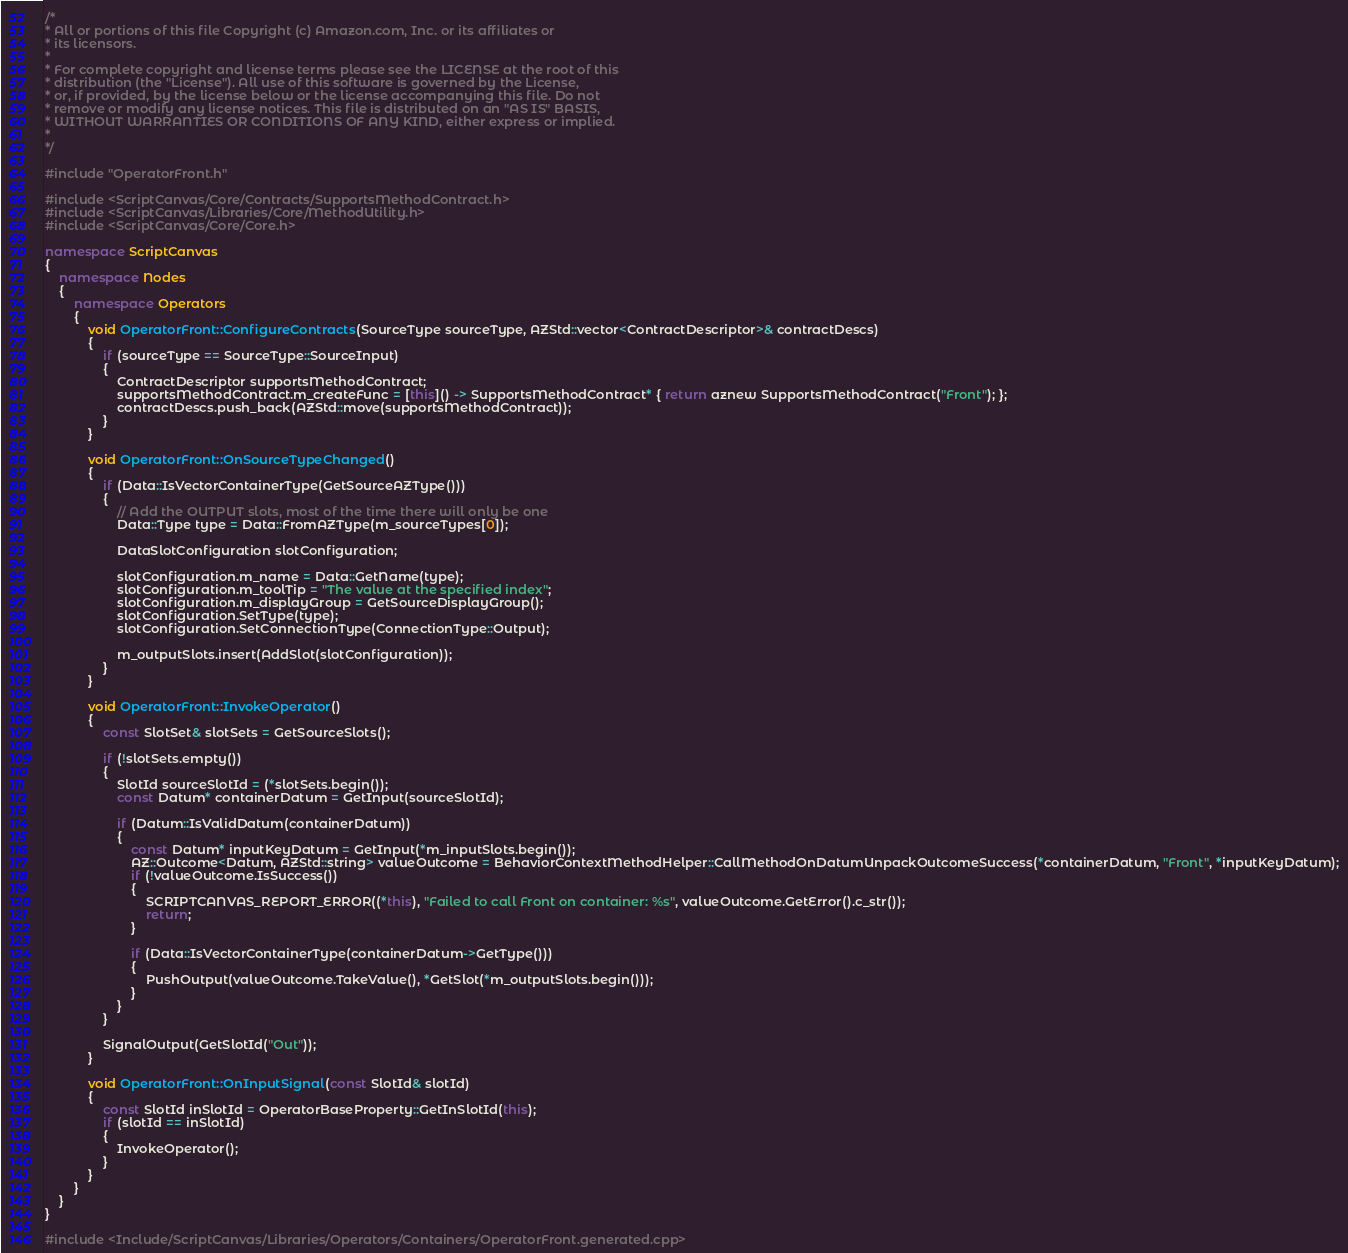<code> <loc_0><loc_0><loc_500><loc_500><_C++_>/*
* All or portions of this file Copyright (c) Amazon.com, Inc. or its affiliates or
* its licensors.
*
* For complete copyright and license terms please see the LICENSE at the root of this
* distribution (the "License"). All use of this software is governed by the License,
* or, if provided, by the license below or the license accompanying this file. Do not
* remove or modify any license notices. This file is distributed on an "AS IS" BASIS,
* WITHOUT WARRANTIES OR CONDITIONS OF ANY KIND, either express or implied.
*
*/

#include "OperatorFront.h"

#include <ScriptCanvas/Core/Contracts/SupportsMethodContract.h>
#include <ScriptCanvas/Libraries/Core/MethodUtility.h>
#include <ScriptCanvas/Core/Core.h>

namespace ScriptCanvas
{
    namespace Nodes
    {
        namespace Operators
        {
            void OperatorFront::ConfigureContracts(SourceType sourceType, AZStd::vector<ContractDescriptor>& contractDescs)
            {
                if (sourceType == SourceType::SourceInput)
                {
                    ContractDescriptor supportsMethodContract;
                    supportsMethodContract.m_createFunc = [this]() -> SupportsMethodContract* { return aznew SupportsMethodContract("Front"); };
                    contractDescs.push_back(AZStd::move(supportsMethodContract));
                }
            }

            void OperatorFront::OnSourceTypeChanged()
            {
                if (Data::IsVectorContainerType(GetSourceAZType()))
                {
                    // Add the OUTPUT slots, most of the time there will only be one
                    Data::Type type = Data::FromAZType(m_sourceTypes[0]);

                    DataSlotConfiguration slotConfiguration;

                    slotConfiguration.m_name = Data::GetName(type);
                    slotConfiguration.m_toolTip = "The value at the specified index";
                    slotConfiguration.m_displayGroup = GetSourceDisplayGroup();
                    slotConfiguration.SetType(type);
                    slotConfiguration.SetConnectionType(ConnectionType::Output);

                    m_outputSlots.insert(AddSlot(slotConfiguration));
                }
            }

            void OperatorFront::InvokeOperator()
            {
                const SlotSet& slotSets = GetSourceSlots();

                if (!slotSets.empty())
                {
                    SlotId sourceSlotId = (*slotSets.begin());
                    const Datum* containerDatum = GetInput(sourceSlotId);

                    if (Datum::IsValidDatum(containerDatum))
                    {
                        const Datum* inputKeyDatum = GetInput(*m_inputSlots.begin());
                        AZ::Outcome<Datum, AZStd::string> valueOutcome = BehaviorContextMethodHelper::CallMethodOnDatumUnpackOutcomeSuccess(*containerDatum, "Front", *inputKeyDatum);
                        if (!valueOutcome.IsSuccess())
                        {
                            SCRIPTCANVAS_REPORT_ERROR((*this), "Failed to call Front on container: %s", valueOutcome.GetError().c_str());
                            return;
                        }

                        if (Data::IsVectorContainerType(containerDatum->GetType()))
                        {
                            PushOutput(valueOutcome.TakeValue(), *GetSlot(*m_outputSlots.begin()));
                        }
                    }
                }

                SignalOutput(GetSlotId("Out"));
            }

            void OperatorFront::OnInputSignal(const SlotId& slotId)
            {
                const SlotId inSlotId = OperatorBaseProperty::GetInSlotId(this);
                if (slotId == inSlotId)
                {
                    InvokeOperator();
                }
            }
        }
    }
}

#include <Include/ScriptCanvas/Libraries/Operators/Containers/OperatorFront.generated.cpp></code> 